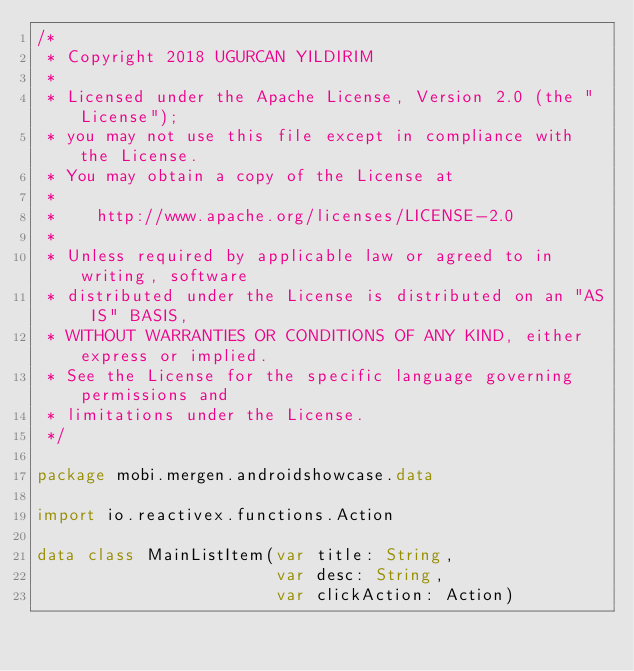<code> <loc_0><loc_0><loc_500><loc_500><_Kotlin_>/*
 * Copyright 2018 UGURCAN YILDIRIM
 *
 * Licensed under the Apache License, Version 2.0 (the "License");
 * you may not use this file except in compliance with the License.
 * You may obtain a copy of the License at
 *
 *    http://www.apache.org/licenses/LICENSE-2.0
 *
 * Unless required by applicable law or agreed to in writing, software
 * distributed under the License is distributed on an "AS IS" BASIS,
 * WITHOUT WARRANTIES OR CONDITIONS OF ANY KIND, either express or implied.
 * See the License for the specific language governing permissions and
 * limitations under the License.
 */

package mobi.mergen.androidshowcase.data

import io.reactivex.functions.Action

data class MainListItem(var title: String,
                        var desc: String,
                        var clickAction: Action)
</code> 